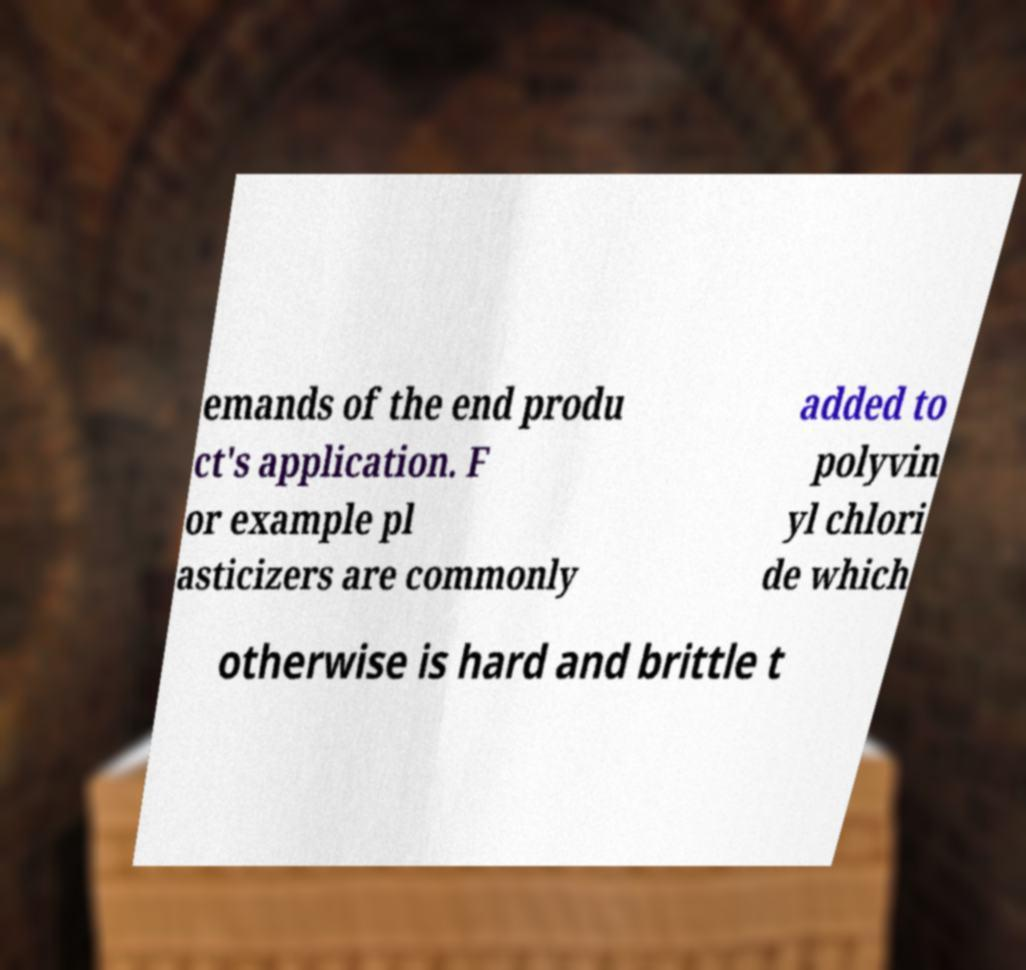Could you extract and type out the text from this image? emands of the end produ ct's application. F or example pl asticizers are commonly added to polyvin yl chlori de which otherwise is hard and brittle t 